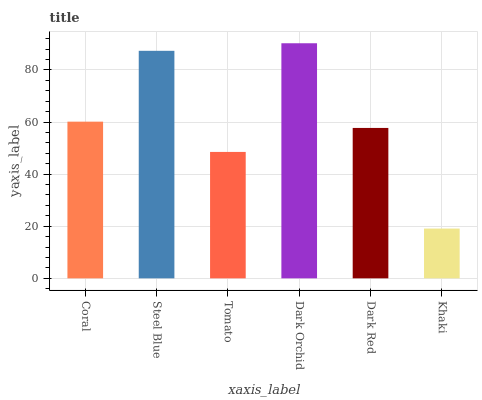Is Khaki the minimum?
Answer yes or no. Yes. Is Dark Orchid the maximum?
Answer yes or no. Yes. Is Steel Blue the minimum?
Answer yes or no. No. Is Steel Blue the maximum?
Answer yes or no. No. Is Steel Blue greater than Coral?
Answer yes or no. Yes. Is Coral less than Steel Blue?
Answer yes or no. Yes. Is Coral greater than Steel Blue?
Answer yes or no. No. Is Steel Blue less than Coral?
Answer yes or no. No. Is Coral the high median?
Answer yes or no. Yes. Is Dark Red the low median?
Answer yes or no. Yes. Is Steel Blue the high median?
Answer yes or no. No. Is Steel Blue the low median?
Answer yes or no. No. 